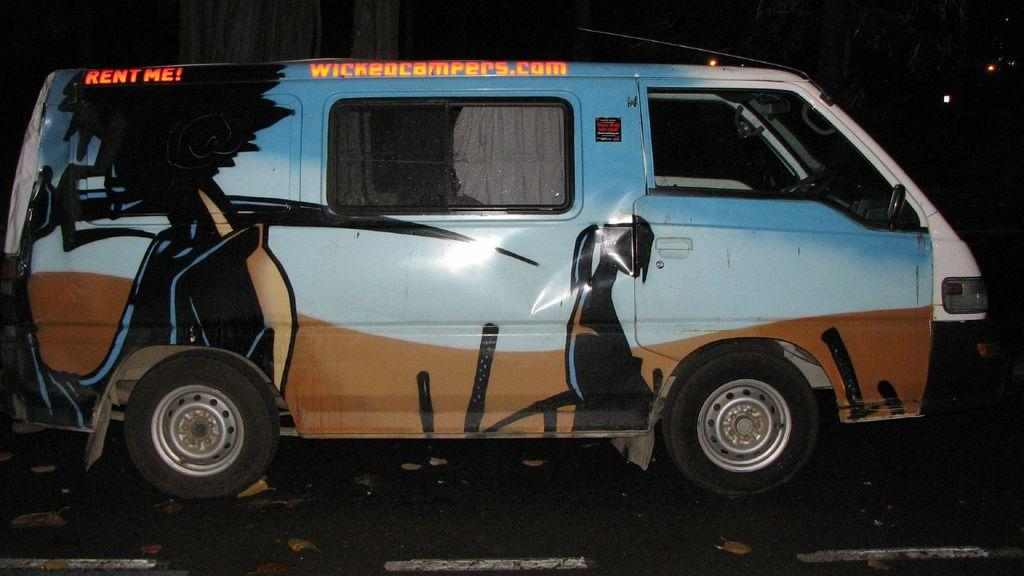What is the main subject of the image? The main subject of the image is a vehicle. Where is the vehicle located in the image? The vehicle is on the road. What can be observed about the background of the image? The background of the image is dark. How many pigs are visible in the image? There are no pigs present in the image. What is the minute detail that can be seen on the vehicle in the image? The facts provided do not mention any specific details about the vehicle, so it is not possible to answer a question about a minute detail. 